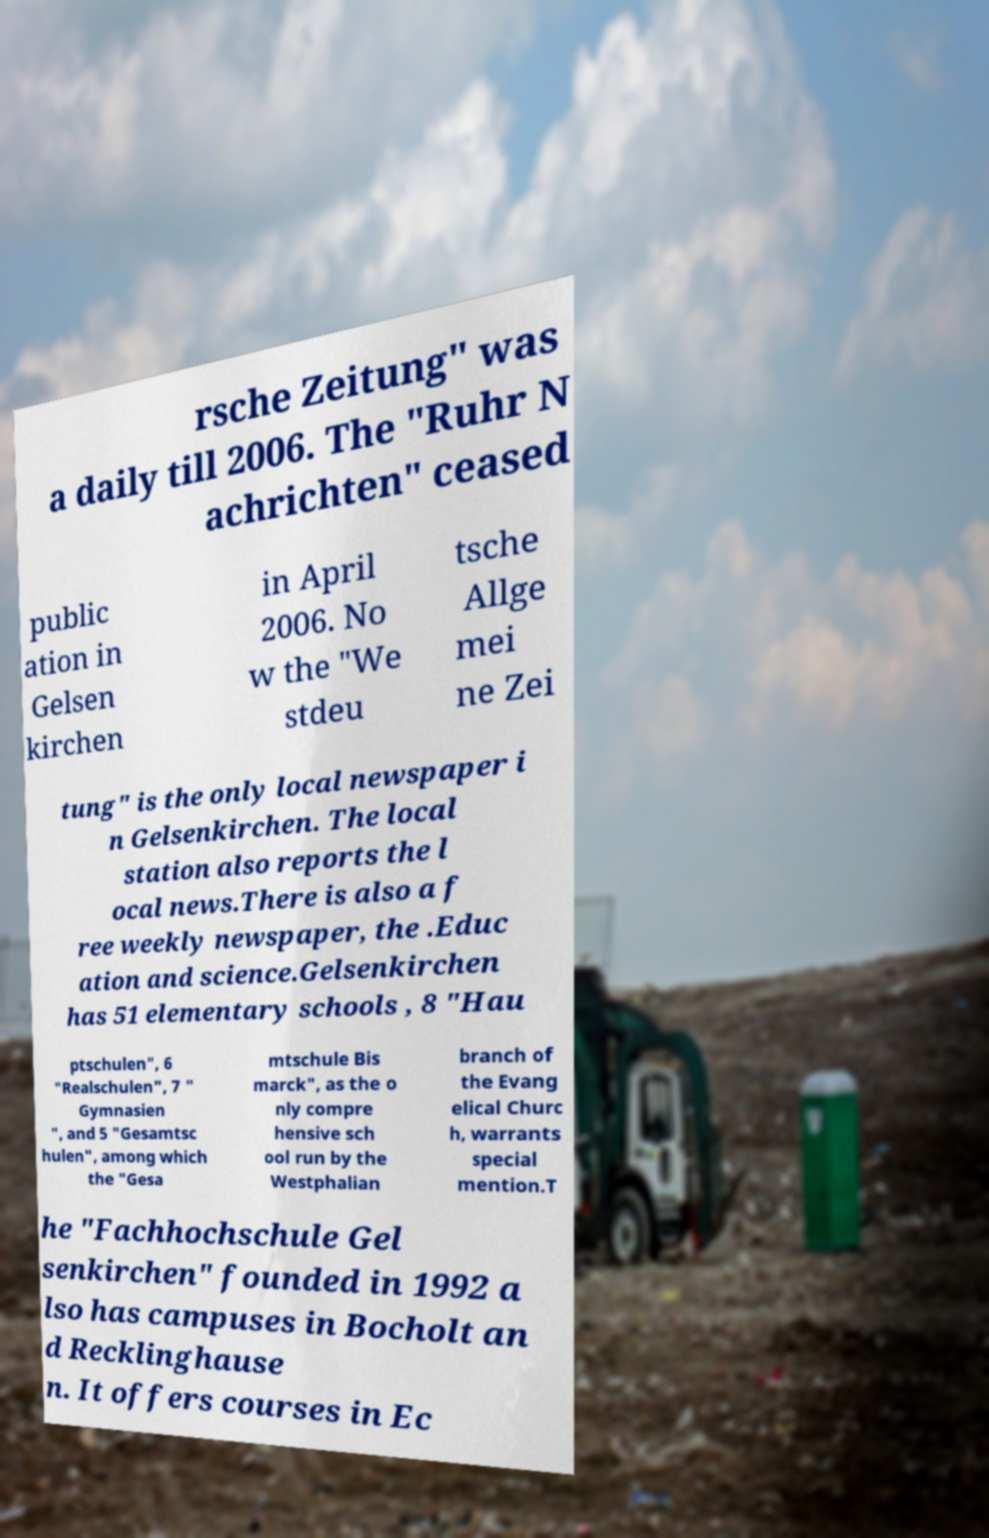Could you extract and type out the text from this image? rsche Zeitung" was a daily till 2006. The "Ruhr N achrichten" ceased public ation in Gelsen kirchen in April 2006. No w the "We stdeu tsche Allge mei ne Zei tung" is the only local newspaper i n Gelsenkirchen. The local station also reports the l ocal news.There is also a f ree weekly newspaper, the .Educ ation and science.Gelsenkirchen has 51 elementary schools , 8 "Hau ptschulen", 6 "Realschulen", 7 " Gymnasien ", and 5 "Gesamtsc hulen", among which the "Gesa mtschule Bis marck", as the o nly compre hensive sch ool run by the Westphalian branch of the Evang elical Churc h, warrants special mention.T he "Fachhochschule Gel senkirchen" founded in 1992 a lso has campuses in Bocholt an d Recklinghause n. It offers courses in Ec 